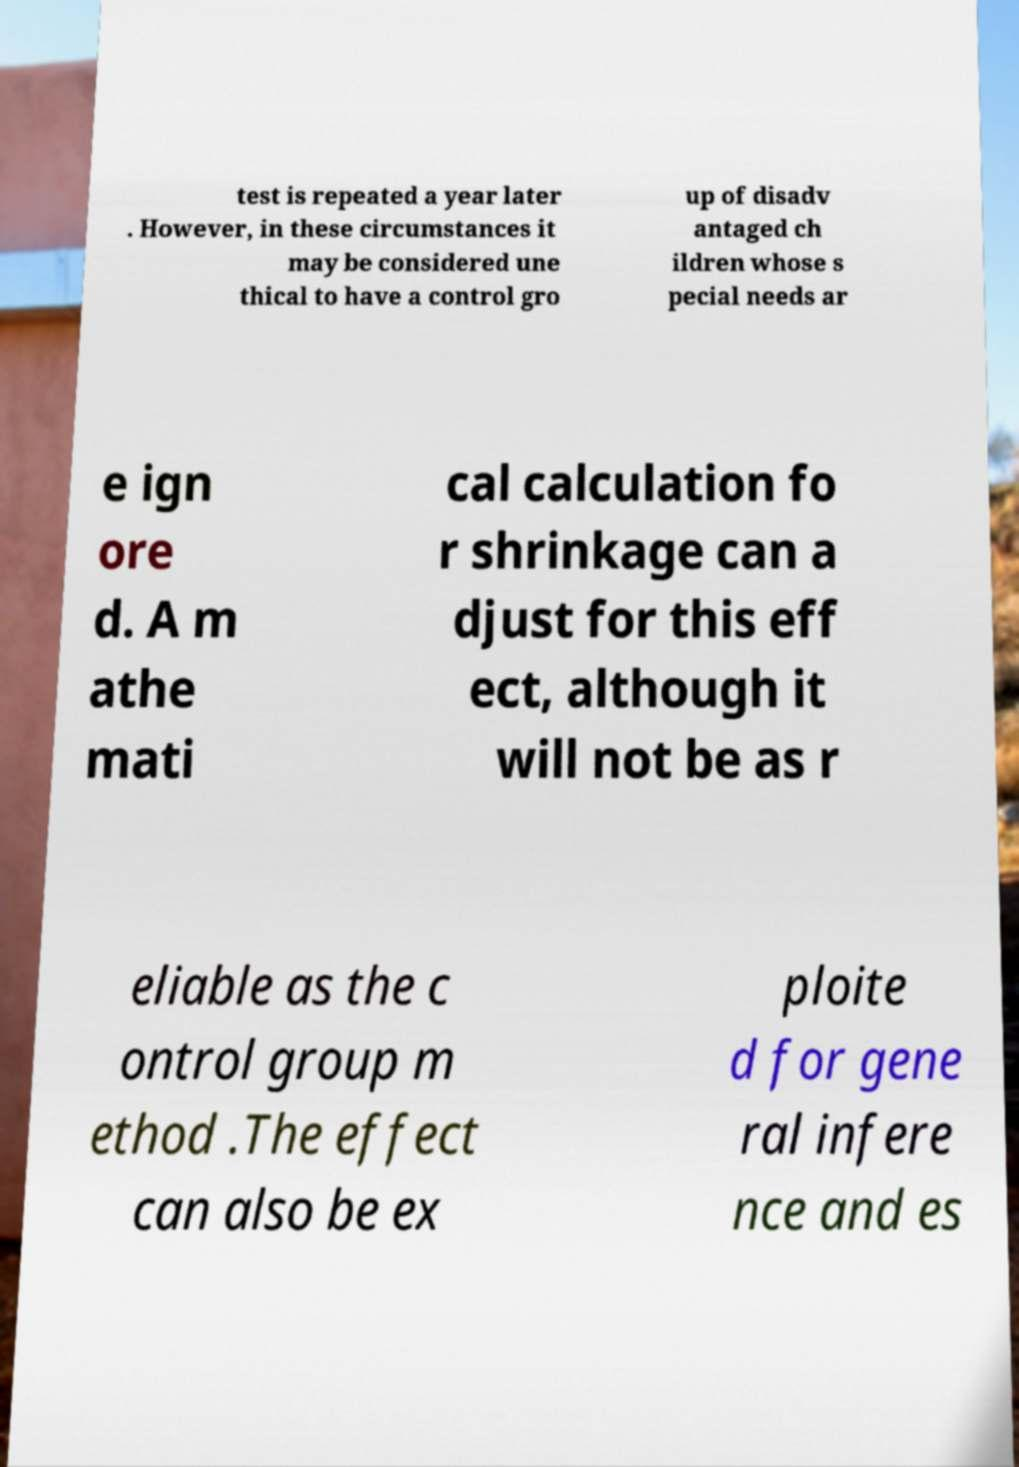Can you accurately transcribe the text from the provided image for me? test is repeated a year later . However, in these circumstances it may be considered une thical to have a control gro up of disadv antaged ch ildren whose s pecial needs ar e ign ore d. A m athe mati cal calculation fo r shrinkage can a djust for this eff ect, although it will not be as r eliable as the c ontrol group m ethod .The effect can also be ex ploite d for gene ral infere nce and es 